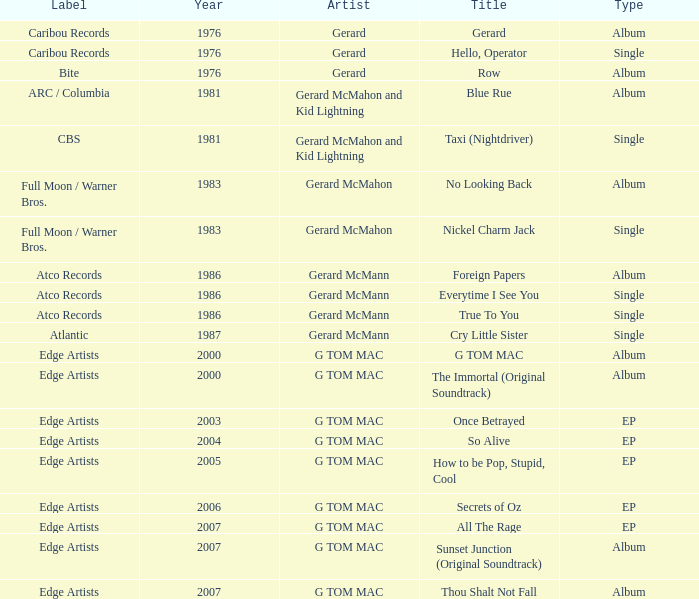Which Title has a Type of album and a Year larger than 1986? G TOM MAC, The Immortal (Original Soundtrack), Sunset Junction (Original Soundtrack), Thou Shalt Not Fall. 